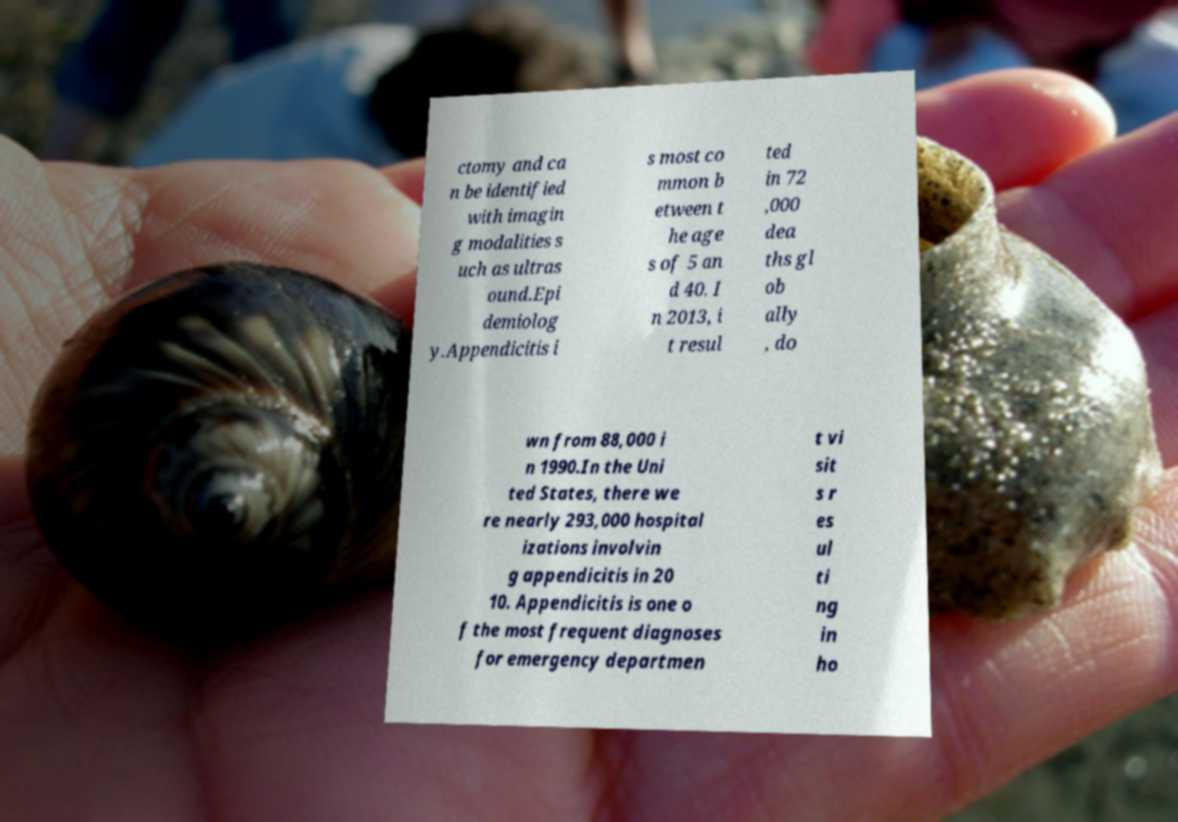I need the written content from this picture converted into text. Can you do that? ctomy and ca n be identified with imagin g modalities s uch as ultras ound.Epi demiolog y.Appendicitis i s most co mmon b etween t he age s of 5 an d 40. I n 2013, i t resul ted in 72 ,000 dea ths gl ob ally , do wn from 88,000 i n 1990.In the Uni ted States, there we re nearly 293,000 hospital izations involvin g appendicitis in 20 10. Appendicitis is one o f the most frequent diagnoses for emergency departmen t vi sit s r es ul ti ng in ho 